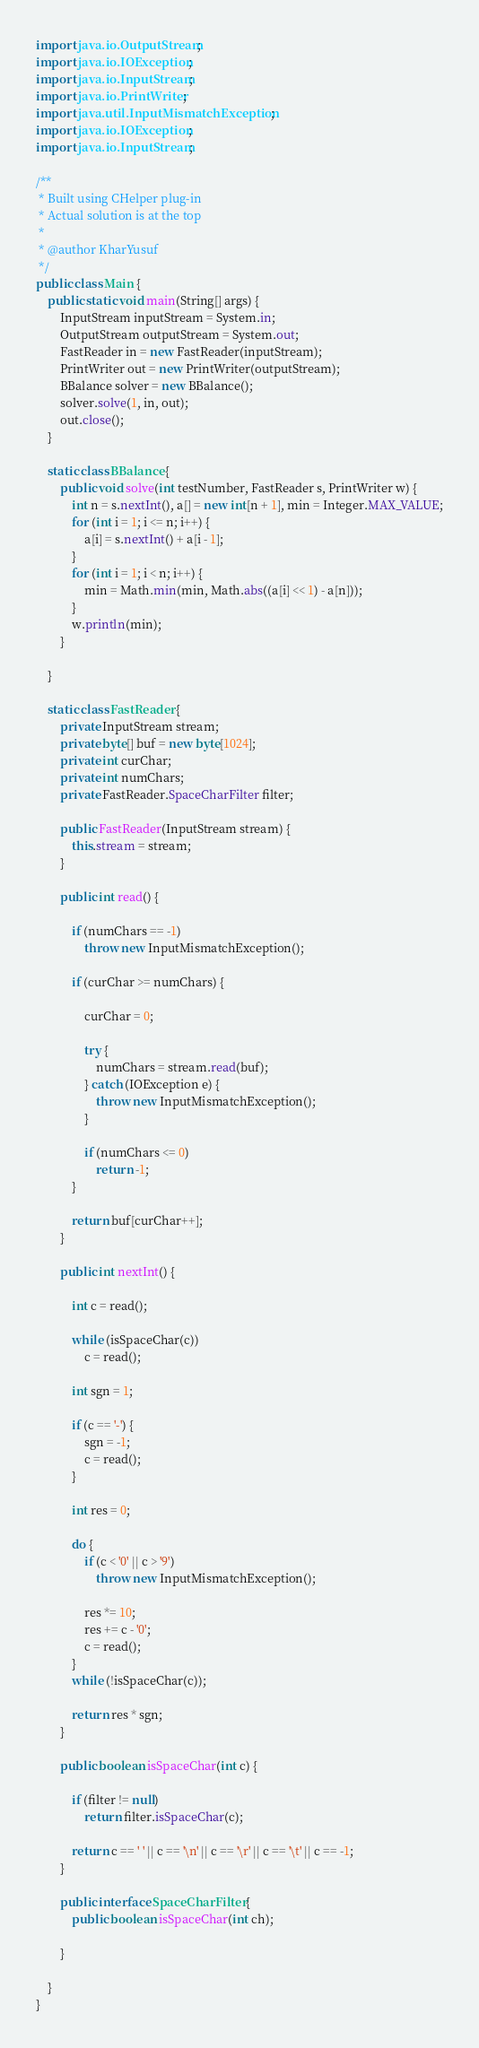Convert code to text. <code><loc_0><loc_0><loc_500><loc_500><_Java_>import java.io.OutputStream;
import java.io.IOException;
import java.io.InputStream;
import java.io.PrintWriter;
import java.util.InputMismatchException;
import java.io.IOException;
import java.io.InputStream;

/**
 * Built using CHelper plug-in
 * Actual solution is at the top
 *
 * @author KharYusuf
 */
public class Main {
    public static void main(String[] args) {
        InputStream inputStream = System.in;
        OutputStream outputStream = System.out;
        FastReader in = new FastReader(inputStream);
        PrintWriter out = new PrintWriter(outputStream);
        BBalance solver = new BBalance();
        solver.solve(1, in, out);
        out.close();
    }

    static class BBalance {
        public void solve(int testNumber, FastReader s, PrintWriter w) {
            int n = s.nextInt(), a[] = new int[n + 1], min = Integer.MAX_VALUE;
            for (int i = 1; i <= n; i++) {
                a[i] = s.nextInt() + a[i - 1];
            }
            for (int i = 1; i < n; i++) {
                min = Math.min(min, Math.abs((a[i] << 1) - a[n]));
            }
            w.println(min);
        }

    }

    static class FastReader {
        private InputStream stream;
        private byte[] buf = new byte[1024];
        private int curChar;
        private int numChars;
        private FastReader.SpaceCharFilter filter;

        public FastReader(InputStream stream) {
            this.stream = stream;
        }

        public int read() {

            if (numChars == -1)
                throw new InputMismatchException();

            if (curChar >= numChars) {

                curChar = 0;

                try {
                    numChars = stream.read(buf);
                } catch (IOException e) {
                    throw new InputMismatchException();
                }

                if (numChars <= 0)
                    return -1;
            }

            return buf[curChar++];
        }

        public int nextInt() {

            int c = read();

            while (isSpaceChar(c))
                c = read();

            int sgn = 1;

            if (c == '-') {
                sgn = -1;
                c = read();
            }

            int res = 0;

            do {
                if (c < '0' || c > '9')
                    throw new InputMismatchException();

                res *= 10;
                res += c - '0';
                c = read();
            }
            while (!isSpaceChar(c));

            return res * sgn;
        }

        public boolean isSpaceChar(int c) {

            if (filter != null)
                return filter.isSpaceChar(c);

            return c == ' ' || c == '\n' || c == '\r' || c == '\t' || c == -1;
        }

        public interface SpaceCharFilter {
            public boolean isSpaceChar(int ch);

        }

    }
}

</code> 